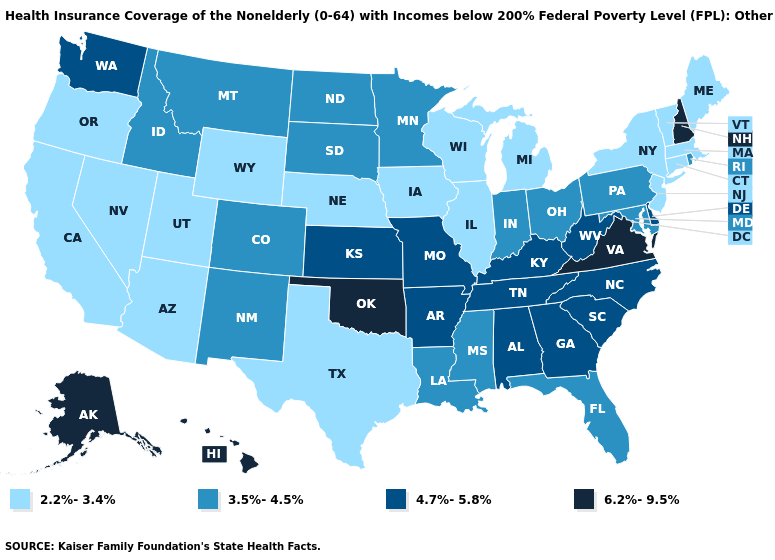Name the states that have a value in the range 2.2%-3.4%?
Quick response, please. Arizona, California, Connecticut, Illinois, Iowa, Maine, Massachusetts, Michigan, Nebraska, Nevada, New Jersey, New York, Oregon, Texas, Utah, Vermont, Wisconsin, Wyoming. Name the states that have a value in the range 4.7%-5.8%?
Quick response, please. Alabama, Arkansas, Delaware, Georgia, Kansas, Kentucky, Missouri, North Carolina, South Carolina, Tennessee, Washington, West Virginia. Name the states that have a value in the range 4.7%-5.8%?
Quick response, please. Alabama, Arkansas, Delaware, Georgia, Kansas, Kentucky, Missouri, North Carolina, South Carolina, Tennessee, Washington, West Virginia. Which states have the lowest value in the Northeast?
Be succinct. Connecticut, Maine, Massachusetts, New Jersey, New York, Vermont. What is the lowest value in the USA?
Answer briefly. 2.2%-3.4%. Does Alaska have the highest value in the West?
Answer briefly. Yes. What is the value of Wisconsin?
Be succinct. 2.2%-3.4%. Among the states that border Maryland , does West Virginia have the lowest value?
Be succinct. No. How many symbols are there in the legend?
Give a very brief answer. 4. Name the states that have a value in the range 6.2%-9.5%?
Be succinct. Alaska, Hawaii, New Hampshire, Oklahoma, Virginia. Does West Virginia have the lowest value in the USA?
Short answer required. No. Among the states that border North Carolina , does Georgia have the highest value?
Answer briefly. No. What is the value of Utah?
Keep it brief. 2.2%-3.4%. Does Tennessee have the same value as Colorado?
Keep it brief. No. What is the value of Oklahoma?
Keep it brief. 6.2%-9.5%. 